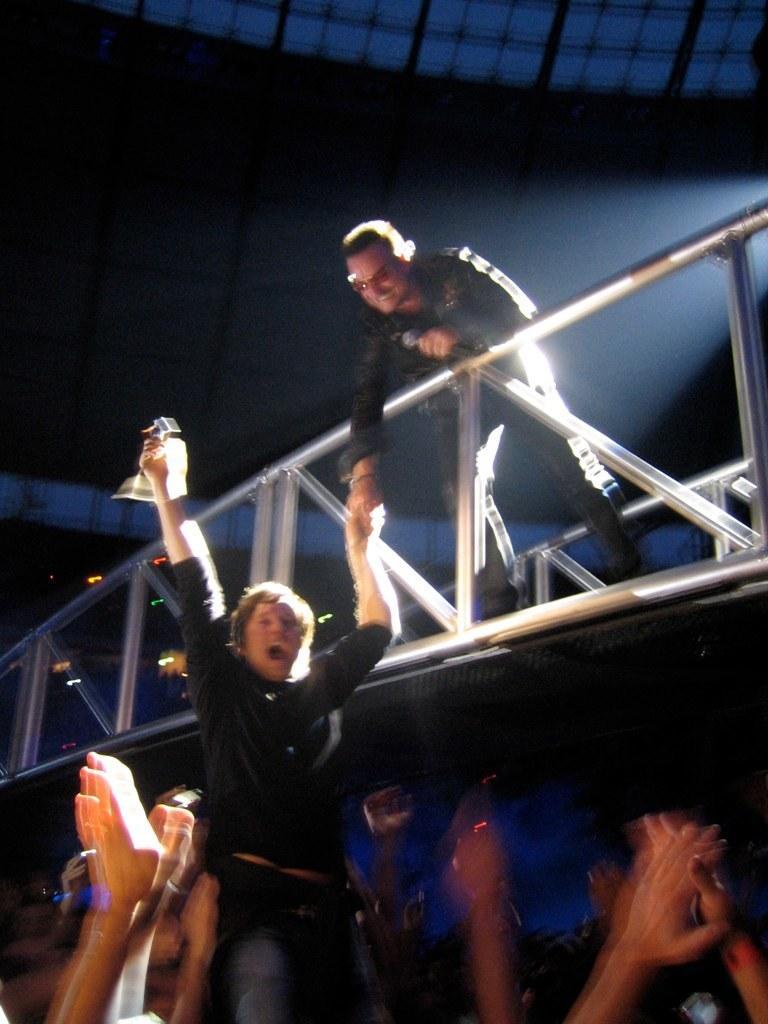In one or two sentences, can you explain what this image depicts? This image consists of a man standing at the top. In the middle, there is a railing made up of metal. He is holding the hand of a boy. At the bottom, there is a huge crowd. At the top, there is a roof. 